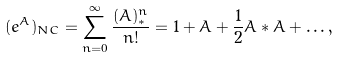<formula> <loc_0><loc_0><loc_500><loc_500>( e ^ { A } ) _ { N C } = \sum _ { n = 0 } ^ { \infty } \frac { ( A ) ^ { n } _ { * } } { n ! } = 1 + A + \frac { 1 } { 2 } A * A + \dots ,</formula> 